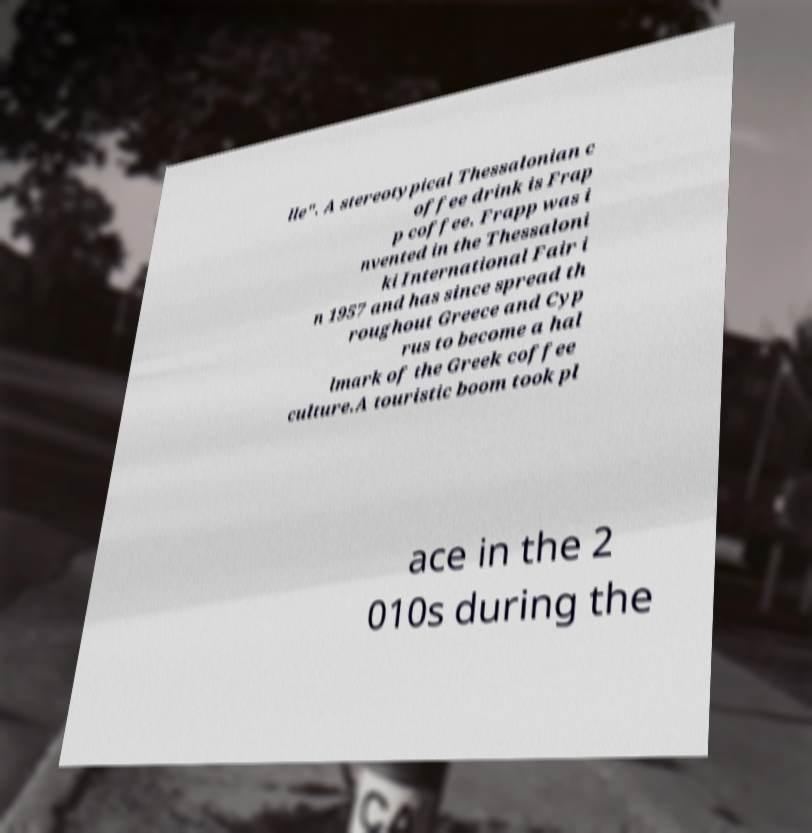Can you read and provide the text displayed in the image?This photo seems to have some interesting text. Can you extract and type it out for me? lle". A stereotypical Thessalonian c offee drink is Frap p coffee. Frapp was i nvented in the Thessaloni ki International Fair i n 1957 and has since spread th roughout Greece and Cyp rus to become a hal lmark of the Greek coffee culture.A touristic boom took pl ace in the 2 010s during the 